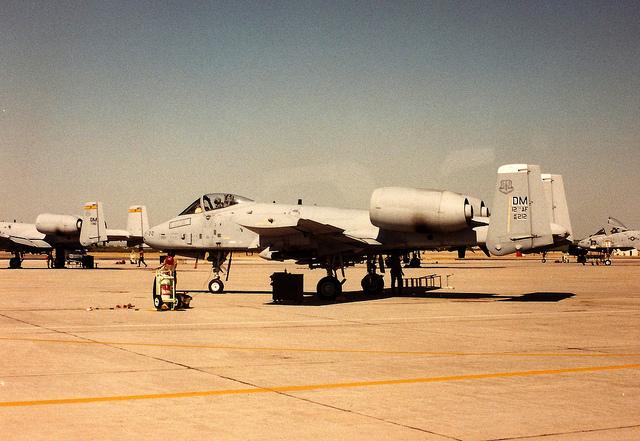Is this a civilian aircraft?
Write a very short answer. No. Is the sun in front of or behind the camera?
Keep it brief. Behind. How many people does this plane carry?
Concise answer only. 2. Who flies these?
Keep it brief. Pilots. 